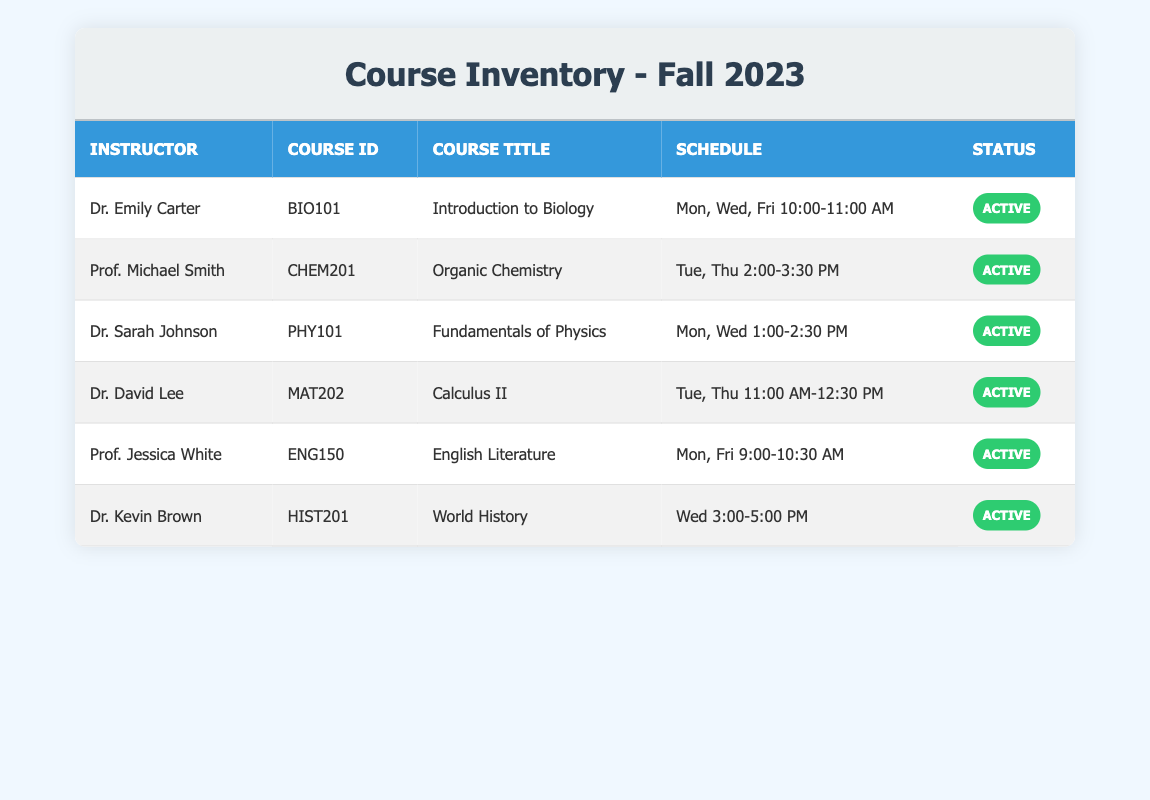What course does Dr. Emily Carter teach? According to the table, the instructor Dr. Emily Carter teaches the course with the ID BIO101, which is titled "Introduction to Biology."
Answer: Introduction to Biology How many courses are scheduled on Mondays? From the table, we can see courses scheduled on Mondays: BIO101, PHY101, ENG150. This gives us a total of 3 courses.
Answer: 3 Is Prof. Michael Smith teaching a course in Fall 2023? Yes, the table indicates that Prof. Michael Smith is assigned to teach Organic Chemistry (CHEM201) during the Fall 2023 semester.
Answer: Yes What is the latest time scheduled for a class? The latest time listed in the table is for Dr. Kevin Brown's World History class, which runs from 3:00 PM to 5:00 PM on Wednesdays. This is confirmed by reviewing all class schedules.
Answer: 5:00 PM Which instructor is teaching the course "Calculus II"? The table shows that Dr. David Lee is the instructor for the course titled "Calculus II," which has the course ID MAT202.
Answer: Dr. David Lee Count how many instructors have classes scheduled on Tuesdays. The table lists two instructors with Tuesday classes: Prof. Michael Smith for Organic Chemistry and Dr. David Lee for Calculus II. Thus, there are 2 instructors.
Answer: 2 Is there any course that has a status other than active? According to the table, all listed courses have a status of "Active." Therefore, there are no courses with a different status.
Answer: No Which courses are scheduled on Wednesdays? The courses scheduled on Wednesdays are PHY101 taught by Dr. Sarah Johnson and HIST201 by Dr. Kevin Brown. Both can be identified from the provided schedule.
Answer: PHY101, HIST201 What is the average number of class sessions per week for all listed courses? Looking at the schedules, BIO101 meets 3 times, CHEM201 meets 2 times, PHY101 meets 2 times, MAT202 meets 2 times, ENG150 meets 2 times, and HIST201 meets 1 time. Thus, the total number of sessions is 3 + 2 + 2 + 2 + 2 + 1 = 12. There are 6 courses, so the average is 12/6 = 2.
Answer: 2 